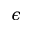<formula> <loc_0><loc_0><loc_500><loc_500>\epsilon</formula> 